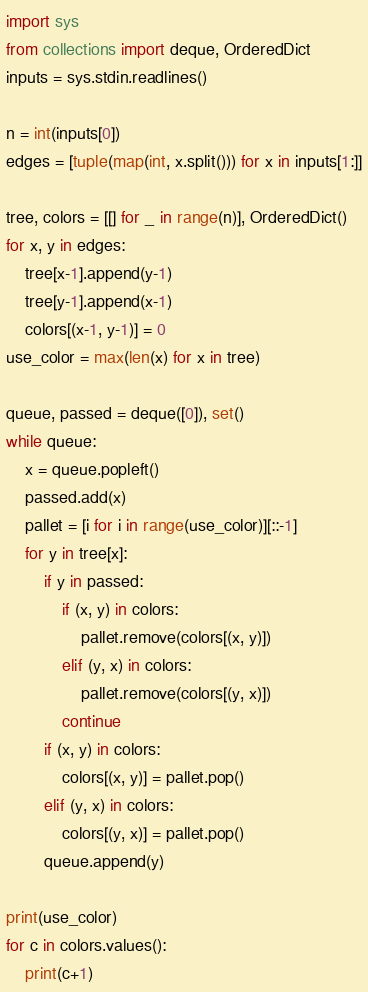<code> <loc_0><loc_0><loc_500><loc_500><_Python_>import sys
from collections import deque, OrderedDict
inputs = sys.stdin.readlines()

n = int(inputs[0])
edges = [tuple(map(int, x.split())) for x in inputs[1:]]

tree, colors = [[] for _ in range(n)], OrderedDict()
for x, y in edges:
    tree[x-1].append(y-1)
    tree[y-1].append(x-1)
    colors[(x-1, y-1)] = 0
use_color = max(len(x) for x in tree)

queue, passed = deque([0]), set()
while queue:
    x = queue.popleft()
    passed.add(x)
    pallet = [i for i in range(use_color)][::-1]
    for y in tree[x]:
        if y in passed:
            if (x, y) in colors:
                pallet.remove(colors[(x, y)])
            elif (y, x) in colors:
                pallet.remove(colors[(y, x)])
            continue
        if (x, y) in colors:
            colors[(x, y)] = pallet.pop()
        elif (y, x) in colors:
            colors[(y, x)] = pallet.pop()
        queue.append(y)

print(use_color)
for c in colors.values():
    print(c+1)</code> 